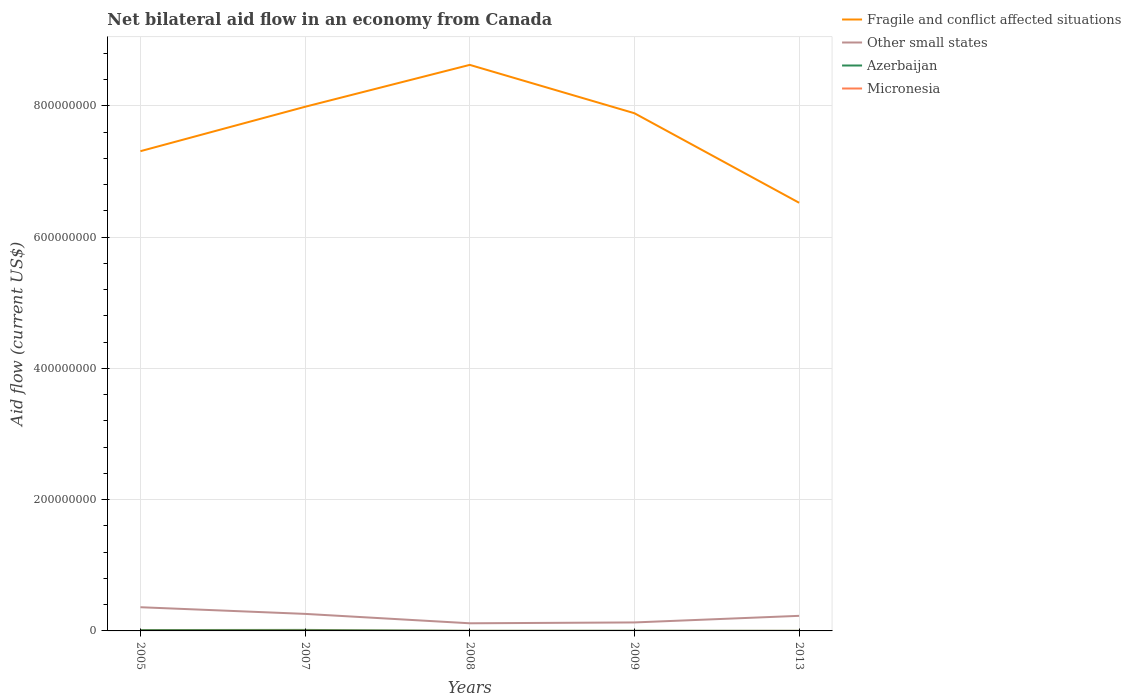Does the line corresponding to Micronesia intersect with the line corresponding to Fragile and conflict affected situations?
Your response must be concise. No. Is the number of lines equal to the number of legend labels?
Make the answer very short. Yes. Across all years, what is the maximum net bilateral aid flow in Azerbaijan?
Ensure brevity in your answer.  1.40e+05. What is the total net bilateral aid flow in Fragile and conflict affected situations in the graph?
Offer a terse response. -6.38e+07. What is the difference between the highest and the second highest net bilateral aid flow in Azerbaijan?
Offer a very short reply. 1.38e+06. What is the difference between the highest and the lowest net bilateral aid flow in Fragile and conflict affected situations?
Offer a terse response. 3. How many lines are there?
Provide a short and direct response. 4. How many years are there in the graph?
Make the answer very short. 5. Are the values on the major ticks of Y-axis written in scientific E-notation?
Make the answer very short. No. Does the graph contain any zero values?
Your response must be concise. No. Does the graph contain grids?
Provide a succinct answer. Yes. Where does the legend appear in the graph?
Ensure brevity in your answer.  Top right. How many legend labels are there?
Ensure brevity in your answer.  4. What is the title of the graph?
Offer a terse response. Net bilateral aid flow in an economy from Canada. Does "Colombia" appear as one of the legend labels in the graph?
Your answer should be compact. No. What is the label or title of the Y-axis?
Make the answer very short. Aid flow (current US$). What is the Aid flow (current US$) of Fragile and conflict affected situations in 2005?
Make the answer very short. 7.31e+08. What is the Aid flow (current US$) of Other small states in 2005?
Your answer should be compact. 3.61e+07. What is the Aid flow (current US$) in Azerbaijan in 2005?
Give a very brief answer. 1.35e+06. What is the Aid flow (current US$) of Micronesia in 2005?
Provide a succinct answer. 2.00e+05. What is the Aid flow (current US$) in Fragile and conflict affected situations in 2007?
Keep it short and to the point. 7.99e+08. What is the Aid flow (current US$) of Other small states in 2007?
Your answer should be compact. 2.60e+07. What is the Aid flow (current US$) in Azerbaijan in 2007?
Give a very brief answer. 1.52e+06. What is the Aid flow (current US$) in Micronesia in 2007?
Your response must be concise. 3.10e+05. What is the Aid flow (current US$) of Fragile and conflict affected situations in 2008?
Offer a terse response. 8.63e+08. What is the Aid flow (current US$) of Other small states in 2008?
Give a very brief answer. 1.16e+07. What is the Aid flow (current US$) in Micronesia in 2008?
Offer a terse response. 2.00e+04. What is the Aid flow (current US$) in Fragile and conflict affected situations in 2009?
Provide a short and direct response. 7.89e+08. What is the Aid flow (current US$) in Other small states in 2009?
Ensure brevity in your answer.  1.29e+07. What is the Aid flow (current US$) in Azerbaijan in 2009?
Your response must be concise. 2.70e+05. What is the Aid flow (current US$) of Fragile and conflict affected situations in 2013?
Provide a short and direct response. 6.52e+08. What is the Aid flow (current US$) in Other small states in 2013?
Give a very brief answer. 2.30e+07. Across all years, what is the maximum Aid flow (current US$) of Fragile and conflict affected situations?
Your response must be concise. 8.63e+08. Across all years, what is the maximum Aid flow (current US$) of Other small states?
Offer a terse response. 3.61e+07. Across all years, what is the maximum Aid flow (current US$) in Azerbaijan?
Your answer should be compact. 1.52e+06. Across all years, what is the maximum Aid flow (current US$) of Micronesia?
Keep it short and to the point. 3.10e+05. Across all years, what is the minimum Aid flow (current US$) in Fragile and conflict affected situations?
Give a very brief answer. 6.52e+08. Across all years, what is the minimum Aid flow (current US$) of Other small states?
Your response must be concise. 1.16e+07. Across all years, what is the minimum Aid flow (current US$) in Micronesia?
Keep it short and to the point. 10000. What is the total Aid flow (current US$) of Fragile and conflict affected situations in the graph?
Your answer should be very brief. 3.83e+09. What is the total Aid flow (current US$) in Other small states in the graph?
Provide a short and direct response. 1.10e+08. What is the total Aid flow (current US$) in Azerbaijan in the graph?
Make the answer very short. 3.44e+06. What is the total Aid flow (current US$) of Micronesia in the graph?
Make the answer very short. 5.80e+05. What is the difference between the Aid flow (current US$) in Fragile and conflict affected situations in 2005 and that in 2007?
Your response must be concise. -6.77e+07. What is the difference between the Aid flow (current US$) in Other small states in 2005 and that in 2007?
Make the answer very short. 1.02e+07. What is the difference between the Aid flow (current US$) in Azerbaijan in 2005 and that in 2007?
Make the answer very short. -1.70e+05. What is the difference between the Aid flow (current US$) in Micronesia in 2005 and that in 2007?
Give a very brief answer. -1.10e+05. What is the difference between the Aid flow (current US$) of Fragile and conflict affected situations in 2005 and that in 2008?
Your answer should be compact. -1.32e+08. What is the difference between the Aid flow (current US$) of Other small states in 2005 and that in 2008?
Provide a succinct answer. 2.45e+07. What is the difference between the Aid flow (current US$) of Azerbaijan in 2005 and that in 2008?
Offer a very short reply. 1.19e+06. What is the difference between the Aid flow (current US$) of Micronesia in 2005 and that in 2008?
Make the answer very short. 1.80e+05. What is the difference between the Aid flow (current US$) of Fragile and conflict affected situations in 2005 and that in 2009?
Keep it short and to the point. -5.78e+07. What is the difference between the Aid flow (current US$) in Other small states in 2005 and that in 2009?
Make the answer very short. 2.32e+07. What is the difference between the Aid flow (current US$) of Azerbaijan in 2005 and that in 2009?
Offer a very short reply. 1.08e+06. What is the difference between the Aid flow (current US$) in Fragile and conflict affected situations in 2005 and that in 2013?
Ensure brevity in your answer.  7.86e+07. What is the difference between the Aid flow (current US$) in Other small states in 2005 and that in 2013?
Provide a succinct answer. 1.31e+07. What is the difference between the Aid flow (current US$) in Azerbaijan in 2005 and that in 2013?
Your answer should be compact. 1.21e+06. What is the difference between the Aid flow (current US$) of Micronesia in 2005 and that in 2013?
Provide a short and direct response. 1.60e+05. What is the difference between the Aid flow (current US$) of Fragile and conflict affected situations in 2007 and that in 2008?
Keep it short and to the point. -6.38e+07. What is the difference between the Aid flow (current US$) of Other small states in 2007 and that in 2008?
Your answer should be compact. 1.43e+07. What is the difference between the Aid flow (current US$) in Azerbaijan in 2007 and that in 2008?
Give a very brief answer. 1.36e+06. What is the difference between the Aid flow (current US$) in Micronesia in 2007 and that in 2008?
Provide a short and direct response. 2.90e+05. What is the difference between the Aid flow (current US$) in Fragile and conflict affected situations in 2007 and that in 2009?
Offer a terse response. 9.86e+06. What is the difference between the Aid flow (current US$) in Other small states in 2007 and that in 2009?
Your answer should be compact. 1.30e+07. What is the difference between the Aid flow (current US$) of Azerbaijan in 2007 and that in 2009?
Provide a short and direct response. 1.25e+06. What is the difference between the Aid flow (current US$) of Fragile and conflict affected situations in 2007 and that in 2013?
Make the answer very short. 1.46e+08. What is the difference between the Aid flow (current US$) of Other small states in 2007 and that in 2013?
Your answer should be very brief. 2.96e+06. What is the difference between the Aid flow (current US$) of Azerbaijan in 2007 and that in 2013?
Make the answer very short. 1.38e+06. What is the difference between the Aid flow (current US$) in Micronesia in 2007 and that in 2013?
Offer a terse response. 2.70e+05. What is the difference between the Aid flow (current US$) of Fragile and conflict affected situations in 2008 and that in 2009?
Offer a terse response. 7.37e+07. What is the difference between the Aid flow (current US$) in Other small states in 2008 and that in 2009?
Your response must be concise. -1.28e+06. What is the difference between the Aid flow (current US$) of Fragile and conflict affected situations in 2008 and that in 2013?
Offer a terse response. 2.10e+08. What is the difference between the Aid flow (current US$) in Other small states in 2008 and that in 2013?
Your answer should be very brief. -1.14e+07. What is the difference between the Aid flow (current US$) in Fragile and conflict affected situations in 2009 and that in 2013?
Your answer should be very brief. 1.36e+08. What is the difference between the Aid flow (current US$) of Other small states in 2009 and that in 2013?
Offer a very short reply. -1.01e+07. What is the difference between the Aid flow (current US$) in Azerbaijan in 2009 and that in 2013?
Give a very brief answer. 1.30e+05. What is the difference between the Aid flow (current US$) of Micronesia in 2009 and that in 2013?
Offer a terse response. -3.00e+04. What is the difference between the Aid flow (current US$) in Fragile and conflict affected situations in 2005 and the Aid flow (current US$) in Other small states in 2007?
Offer a very short reply. 7.05e+08. What is the difference between the Aid flow (current US$) in Fragile and conflict affected situations in 2005 and the Aid flow (current US$) in Azerbaijan in 2007?
Your response must be concise. 7.30e+08. What is the difference between the Aid flow (current US$) of Fragile and conflict affected situations in 2005 and the Aid flow (current US$) of Micronesia in 2007?
Provide a short and direct response. 7.31e+08. What is the difference between the Aid flow (current US$) in Other small states in 2005 and the Aid flow (current US$) in Azerbaijan in 2007?
Provide a short and direct response. 3.46e+07. What is the difference between the Aid flow (current US$) of Other small states in 2005 and the Aid flow (current US$) of Micronesia in 2007?
Your response must be concise. 3.58e+07. What is the difference between the Aid flow (current US$) of Azerbaijan in 2005 and the Aid flow (current US$) of Micronesia in 2007?
Offer a very short reply. 1.04e+06. What is the difference between the Aid flow (current US$) of Fragile and conflict affected situations in 2005 and the Aid flow (current US$) of Other small states in 2008?
Provide a short and direct response. 7.19e+08. What is the difference between the Aid flow (current US$) of Fragile and conflict affected situations in 2005 and the Aid flow (current US$) of Azerbaijan in 2008?
Your response must be concise. 7.31e+08. What is the difference between the Aid flow (current US$) in Fragile and conflict affected situations in 2005 and the Aid flow (current US$) in Micronesia in 2008?
Your answer should be compact. 7.31e+08. What is the difference between the Aid flow (current US$) in Other small states in 2005 and the Aid flow (current US$) in Azerbaijan in 2008?
Provide a short and direct response. 3.60e+07. What is the difference between the Aid flow (current US$) in Other small states in 2005 and the Aid flow (current US$) in Micronesia in 2008?
Your answer should be compact. 3.61e+07. What is the difference between the Aid flow (current US$) of Azerbaijan in 2005 and the Aid flow (current US$) of Micronesia in 2008?
Keep it short and to the point. 1.33e+06. What is the difference between the Aid flow (current US$) of Fragile and conflict affected situations in 2005 and the Aid flow (current US$) of Other small states in 2009?
Provide a succinct answer. 7.18e+08. What is the difference between the Aid flow (current US$) in Fragile and conflict affected situations in 2005 and the Aid flow (current US$) in Azerbaijan in 2009?
Your response must be concise. 7.31e+08. What is the difference between the Aid flow (current US$) of Fragile and conflict affected situations in 2005 and the Aid flow (current US$) of Micronesia in 2009?
Make the answer very short. 7.31e+08. What is the difference between the Aid flow (current US$) of Other small states in 2005 and the Aid flow (current US$) of Azerbaijan in 2009?
Your answer should be compact. 3.58e+07. What is the difference between the Aid flow (current US$) of Other small states in 2005 and the Aid flow (current US$) of Micronesia in 2009?
Your answer should be very brief. 3.61e+07. What is the difference between the Aid flow (current US$) in Azerbaijan in 2005 and the Aid flow (current US$) in Micronesia in 2009?
Offer a very short reply. 1.34e+06. What is the difference between the Aid flow (current US$) of Fragile and conflict affected situations in 2005 and the Aid flow (current US$) of Other small states in 2013?
Make the answer very short. 7.08e+08. What is the difference between the Aid flow (current US$) of Fragile and conflict affected situations in 2005 and the Aid flow (current US$) of Azerbaijan in 2013?
Provide a short and direct response. 7.31e+08. What is the difference between the Aid flow (current US$) in Fragile and conflict affected situations in 2005 and the Aid flow (current US$) in Micronesia in 2013?
Make the answer very short. 7.31e+08. What is the difference between the Aid flow (current US$) of Other small states in 2005 and the Aid flow (current US$) of Azerbaijan in 2013?
Offer a very short reply. 3.60e+07. What is the difference between the Aid flow (current US$) of Other small states in 2005 and the Aid flow (current US$) of Micronesia in 2013?
Offer a very short reply. 3.61e+07. What is the difference between the Aid flow (current US$) of Azerbaijan in 2005 and the Aid flow (current US$) of Micronesia in 2013?
Your response must be concise. 1.31e+06. What is the difference between the Aid flow (current US$) in Fragile and conflict affected situations in 2007 and the Aid flow (current US$) in Other small states in 2008?
Your answer should be compact. 7.87e+08. What is the difference between the Aid flow (current US$) in Fragile and conflict affected situations in 2007 and the Aid flow (current US$) in Azerbaijan in 2008?
Keep it short and to the point. 7.99e+08. What is the difference between the Aid flow (current US$) of Fragile and conflict affected situations in 2007 and the Aid flow (current US$) of Micronesia in 2008?
Give a very brief answer. 7.99e+08. What is the difference between the Aid flow (current US$) of Other small states in 2007 and the Aid flow (current US$) of Azerbaijan in 2008?
Your answer should be compact. 2.58e+07. What is the difference between the Aid flow (current US$) of Other small states in 2007 and the Aid flow (current US$) of Micronesia in 2008?
Provide a short and direct response. 2.59e+07. What is the difference between the Aid flow (current US$) in Azerbaijan in 2007 and the Aid flow (current US$) in Micronesia in 2008?
Ensure brevity in your answer.  1.50e+06. What is the difference between the Aid flow (current US$) in Fragile and conflict affected situations in 2007 and the Aid flow (current US$) in Other small states in 2009?
Your response must be concise. 7.86e+08. What is the difference between the Aid flow (current US$) in Fragile and conflict affected situations in 2007 and the Aid flow (current US$) in Azerbaijan in 2009?
Provide a short and direct response. 7.99e+08. What is the difference between the Aid flow (current US$) of Fragile and conflict affected situations in 2007 and the Aid flow (current US$) of Micronesia in 2009?
Make the answer very short. 7.99e+08. What is the difference between the Aid flow (current US$) of Other small states in 2007 and the Aid flow (current US$) of Azerbaijan in 2009?
Give a very brief answer. 2.57e+07. What is the difference between the Aid flow (current US$) of Other small states in 2007 and the Aid flow (current US$) of Micronesia in 2009?
Offer a terse response. 2.59e+07. What is the difference between the Aid flow (current US$) of Azerbaijan in 2007 and the Aid flow (current US$) of Micronesia in 2009?
Keep it short and to the point. 1.51e+06. What is the difference between the Aid flow (current US$) in Fragile and conflict affected situations in 2007 and the Aid flow (current US$) in Other small states in 2013?
Ensure brevity in your answer.  7.76e+08. What is the difference between the Aid flow (current US$) in Fragile and conflict affected situations in 2007 and the Aid flow (current US$) in Azerbaijan in 2013?
Ensure brevity in your answer.  7.99e+08. What is the difference between the Aid flow (current US$) of Fragile and conflict affected situations in 2007 and the Aid flow (current US$) of Micronesia in 2013?
Your answer should be compact. 7.99e+08. What is the difference between the Aid flow (current US$) in Other small states in 2007 and the Aid flow (current US$) in Azerbaijan in 2013?
Make the answer very short. 2.58e+07. What is the difference between the Aid flow (current US$) of Other small states in 2007 and the Aid flow (current US$) of Micronesia in 2013?
Keep it short and to the point. 2.59e+07. What is the difference between the Aid flow (current US$) in Azerbaijan in 2007 and the Aid flow (current US$) in Micronesia in 2013?
Give a very brief answer. 1.48e+06. What is the difference between the Aid flow (current US$) in Fragile and conflict affected situations in 2008 and the Aid flow (current US$) in Other small states in 2009?
Keep it short and to the point. 8.50e+08. What is the difference between the Aid flow (current US$) in Fragile and conflict affected situations in 2008 and the Aid flow (current US$) in Azerbaijan in 2009?
Keep it short and to the point. 8.62e+08. What is the difference between the Aid flow (current US$) of Fragile and conflict affected situations in 2008 and the Aid flow (current US$) of Micronesia in 2009?
Offer a terse response. 8.63e+08. What is the difference between the Aid flow (current US$) in Other small states in 2008 and the Aid flow (current US$) in Azerbaijan in 2009?
Provide a succinct answer. 1.14e+07. What is the difference between the Aid flow (current US$) in Other small states in 2008 and the Aid flow (current US$) in Micronesia in 2009?
Provide a succinct answer. 1.16e+07. What is the difference between the Aid flow (current US$) of Azerbaijan in 2008 and the Aid flow (current US$) of Micronesia in 2009?
Provide a short and direct response. 1.50e+05. What is the difference between the Aid flow (current US$) in Fragile and conflict affected situations in 2008 and the Aid flow (current US$) in Other small states in 2013?
Provide a short and direct response. 8.40e+08. What is the difference between the Aid flow (current US$) in Fragile and conflict affected situations in 2008 and the Aid flow (current US$) in Azerbaijan in 2013?
Offer a very short reply. 8.63e+08. What is the difference between the Aid flow (current US$) in Fragile and conflict affected situations in 2008 and the Aid flow (current US$) in Micronesia in 2013?
Ensure brevity in your answer.  8.63e+08. What is the difference between the Aid flow (current US$) of Other small states in 2008 and the Aid flow (current US$) of Azerbaijan in 2013?
Offer a very short reply. 1.15e+07. What is the difference between the Aid flow (current US$) of Other small states in 2008 and the Aid flow (current US$) of Micronesia in 2013?
Offer a very short reply. 1.16e+07. What is the difference between the Aid flow (current US$) in Fragile and conflict affected situations in 2009 and the Aid flow (current US$) in Other small states in 2013?
Your answer should be very brief. 7.66e+08. What is the difference between the Aid flow (current US$) of Fragile and conflict affected situations in 2009 and the Aid flow (current US$) of Azerbaijan in 2013?
Provide a short and direct response. 7.89e+08. What is the difference between the Aid flow (current US$) in Fragile and conflict affected situations in 2009 and the Aid flow (current US$) in Micronesia in 2013?
Your response must be concise. 7.89e+08. What is the difference between the Aid flow (current US$) in Other small states in 2009 and the Aid flow (current US$) in Azerbaijan in 2013?
Provide a succinct answer. 1.28e+07. What is the difference between the Aid flow (current US$) in Other small states in 2009 and the Aid flow (current US$) in Micronesia in 2013?
Your response must be concise. 1.29e+07. What is the difference between the Aid flow (current US$) of Azerbaijan in 2009 and the Aid flow (current US$) of Micronesia in 2013?
Offer a very short reply. 2.30e+05. What is the average Aid flow (current US$) of Fragile and conflict affected situations per year?
Provide a succinct answer. 7.67e+08. What is the average Aid flow (current US$) of Other small states per year?
Your answer should be compact. 2.19e+07. What is the average Aid flow (current US$) in Azerbaijan per year?
Offer a terse response. 6.88e+05. What is the average Aid flow (current US$) in Micronesia per year?
Give a very brief answer. 1.16e+05. In the year 2005, what is the difference between the Aid flow (current US$) in Fragile and conflict affected situations and Aid flow (current US$) in Other small states?
Keep it short and to the point. 6.95e+08. In the year 2005, what is the difference between the Aid flow (current US$) of Fragile and conflict affected situations and Aid flow (current US$) of Azerbaijan?
Provide a succinct answer. 7.30e+08. In the year 2005, what is the difference between the Aid flow (current US$) in Fragile and conflict affected situations and Aid flow (current US$) in Micronesia?
Offer a very short reply. 7.31e+08. In the year 2005, what is the difference between the Aid flow (current US$) in Other small states and Aid flow (current US$) in Azerbaijan?
Your answer should be compact. 3.48e+07. In the year 2005, what is the difference between the Aid flow (current US$) in Other small states and Aid flow (current US$) in Micronesia?
Ensure brevity in your answer.  3.59e+07. In the year 2005, what is the difference between the Aid flow (current US$) of Azerbaijan and Aid flow (current US$) of Micronesia?
Make the answer very short. 1.15e+06. In the year 2007, what is the difference between the Aid flow (current US$) in Fragile and conflict affected situations and Aid flow (current US$) in Other small states?
Your response must be concise. 7.73e+08. In the year 2007, what is the difference between the Aid flow (current US$) in Fragile and conflict affected situations and Aid flow (current US$) in Azerbaijan?
Ensure brevity in your answer.  7.97e+08. In the year 2007, what is the difference between the Aid flow (current US$) of Fragile and conflict affected situations and Aid flow (current US$) of Micronesia?
Keep it short and to the point. 7.98e+08. In the year 2007, what is the difference between the Aid flow (current US$) of Other small states and Aid flow (current US$) of Azerbaijan?
Give a very brief answer. 2.44e+07. In the year 2007, what is the difference between the Aid flow (current US$) in Other small states and Aid flow (current US$) in Micronesia?
Offer a very short reply. 2.56e+07. In the year 2007, what is the difference between the Aid flow (current US$) in Azerbaijan and Aid flow (current US$) in Micronesia?
Provide a succinct answer. 1.21e+06. In the year 2008, what is the difference between the Aid flow (current US$) in Fragile and conflict affected situations and Aid flow (current US$) in Other small states?
Ensure brevity in your answer.  8.51e+08. In the year 2008, what is the difference between the Aid flow (current US$) of Fragile and conflict affected situations and Aid flow (current US$) of Azerbaijan?
Your answer should be compact. 8.62e+08. In the year 2008, what is the difference between the Aid flow (current US$) in Fragile and conflict affected situations and Aid flow (current US$) in Micronesia?
Offer a very short reply. 8.63e+08. In the year 2008, what is the difference between the Aid flow (current US$) of Other small states and Aid flow (current US$) of Azerbaijan?
Offer a terse response. 1.15e+07. In the year 2008, what is the difference between the Aid flow (current US$) of Other small states and Aid flow (current US$) of Micronesia?
Your response must be concise. 1.16e+07. In the year 2009, what is the difference between the Aid flow (current US$) in Fragile and conflict affected situations and Aid flow (current US$) in Other small states?
Provide a short and direct response. 7.76e+08. In the year 2009, what is the difference between the Aid flow (current US$) in Fragile and conflict affected situations and Aid flow (current US$) in Azerbaijan?
Your response must be concise. 7.89e+08. In the year 2009, what is the difference between the Aid flow (current US$) of Fragile and conflict affected situations and Aid flow (current US$) of Micronesia?
Your response must be concise. 7.89e+08. In the year 2009, what is the difference between the Aid flow (current US$) of Other small states and Aid flow (current US$) of Azerbaijan?
Give a very brief answer. 1.26e+07. In the year 2009, what is the difference between the Aid flow (current US$) of Other small states and Aid flow (current US$) of Micronesia?
Offer a terse response. 1.29e+07. In the year 2009, what is the difference between the Aid flow (current US$) of Azerbaijan and Aid flow (current US$) of Micronesia?
Offer a terse response. 2.60e+05. In the year 2013, what is the difference between the Aid flow (current US$) in Fragile and conflict affected situations and Aid flow (current US$) in Other small states?
Give a very brief answer. 6.30e+08. In the year 2013, what is the difference between the Aid flow (current US$) in Fragile and conflict affected situations and Aid flow (current US$) in Azerbaijan?
Offer a terse response. 6.52e+08. In the year 2013, what is the difference between the Aid flow (current US$) in Fragile and conflict affected situations and Aid flow (current US$) in Micronesia?
Give a very brief answer. 6.52e+08. In the year 2013, what is the difference between the Aid flow (current US$) of Other small states and Aid flow (current US$) of Azerbaijan?
Provide a succinct answer. 2.28e+07. In the year 2013, what is the difference between the Aid flow (current US$) of Other small states and Aid flow (current US$) of Micronesia?
Your response must be concise. 2.30e+07. In the year 2013, what is the difference between the Aid flow (current US$) of Azerbaijan and Aid flow (current US$) of Micronesia?
Your answer should be very brief. 1.00e+05. What is the ratio of the Aid flow (current US$) in Fragile and conflict affected situations in 2005 to that in 2007?
Offer a very short reply. 0.92. What is the ratio of the Aid flow (current US$) in Other small states in 2005 to that in 2007?
Keep it short and to the point. 1.39. What is the ratio of the Aid flow (current US$) of Azerbaijan in 2005 to that in 2007?
Ensure brevity in your answer.  0.89. What is the ratio of the Aid flow (current US$) in Micronesia in 2005 to that in 2007?
Provide a short and direct response. 0.65. What is the ratio of the Aid flow (current US$) of Fragile and conflict affected situations in 2005 to that in 2008?
Offer a terse response. 0.85. What is the ratio of the Aid flow (current US$) of Other small states in 2005 to that in 2008?
Provide a short and direct response. 3.1. What is the ratio of the Aid flow (current US$) in Azerbaijan in 2005 to that in 2008?
Give a very brief answer. 8.44. What is the ratio of the Aid flow (current US$) in Fragile and conflict affected situations in 2005 to that in 2009?
Your answer should be very brief. 0.93. What is the ratio of the Aid flow (current US$) of Other small states in 2005 to that in 2009?
Your answer should be very brief. 2.79. What is the ratio of the Aid flow (current US$) of Fragile and conflict affected situations in 2005 to that in 2013?
Give a very brief answer. 1.12. What is the ratio of the Aid flow (current US$) of Other small states in 2005 to that in 2013?
Your response must be concise. 1.57. What is the ratio of the Aid flow (current US$) of Azerbaijan in 2005 to that in 2013?
Offer a terse response. 9.64. What is the ratio of the Aid flow (current US$) of Micronesia in 2005 to that in 2013?
Your answer should be compact. 5. What is the ratio of the Aid flow (current US$) of Fragile and conflict affected situations in 2007 to that in 2008?
Provide a short and direct response. 0.93. What is the ratio of the Aid flow (current US$) in Other small states in 2007 to that in 2008?
Keep it short and to the point. 2.23. What is the ratio of the Aid flow (current US$) in Fragile and conflict affected situations in 2007 to that in 2009?
Keep it short and to the point. 1.01. What is the ratio of the Aid flow (current US$) of Other small states in 2007 to that in 2009?
Provide a succinct answer. 2.01. What is the ratio of the Aid flow (current US$) of Azerbaijan in 2007 to that in 2009?
Your answer should be compact. 5.63. What is the ratio of the Aid flow (current US$) of Micronesia in 2007 to that in 2009?
Offer a very short reply. 31. What is the ratio of the Aid flow (current US$) of Fragile and conflict affected situations in 2007 to that in 2013?
Make the answer very short. 1.22. What is the ratio of the Aid flow (current US$) in Other small states in 2007 to that in 2013?
Your answer should be very brief. 1.13. What is the ratio of the Aid flow (current US$) in Azerbaijan in 2007 to that in 2013?
Make the answer very short. 10.86. What is the ratio of the Aid flow (current US$) in Micronesia in 2007 to that in 2013?
Make the answer very short. 7.75. What is the ratio of the Aid flow (current US$) of Fragile and conflict affected situations in 2008 to that in 2009?
Keep it short and to the point. 1.09. What is the ratio of the Aid flow (current US$) of Other small states in 2008 to that in 2009?
Ensure brevity in your answer.  0.9. What is the ratio of the Aid flow (current US$) in Azerbaijan in 2008 to that in 2009?
Ensure brevity in your answer.  0.59. What is the ratio of the Aid flow (current US$) of Fragile and conflict affected situations in 2008 to that in 2013?
Keep it short and to the point. 1.32. What is the ratio of the Aid flow (current US$) in Other small states in 2008 to that in 2013?
Provide a short and direct response. 0.51. What is the ratio of the Aid flow (current US$) in Micronesia in 2008 to that in 2013?
Provide a succinct answer. 0.5. What is the ratio of the Aid flow (current US$) of Fragile and conflict affected situations in 2009 to that in 2013?
Ensure brevity in your answer.  1.21. What is the ratio of the Aid flow (current US$) in Other small states in 2009 to that in 2013?
Give a very brief answer. 0.56. What is the ratio of the Aid flow (current US$) in Azerbaijan in 2009 to that in 2013?
Provide a succinct answer. 1.93. What is the difference between the highest and the second highest Aid flow (current US$) in Fragile and conflict affected situations?
Offer a very short reply. 6.38e+07. What is the difference between the highest and the second highest Aid flow (current US$) in Other small states?
Your response must be concise. 1.02e+07. What is the difference between the highest and the second highest Aid flow (current US$) in Azerbaijan?
Make the answer very short. 1.70e+05. What is the difference between the highest and the lowest Aid flow (current US$) of Fragile and conflict affected situations?
Your answer should be very brief. 2.10e+08. What is the difference between the highest and the lowest Aid flow (current US$) of Other small states?
Offer a terse response. 2.45e+07. What is the difference between the highest and the lowest Aid flow (current US$) of Azerbaijan?
Keep it short and to the point. 1.38e+06. What is the difference between the highest and the lowest Aid flow (current US$) in Micronesia?
Keep it short and to the point. 3.00e+05. 